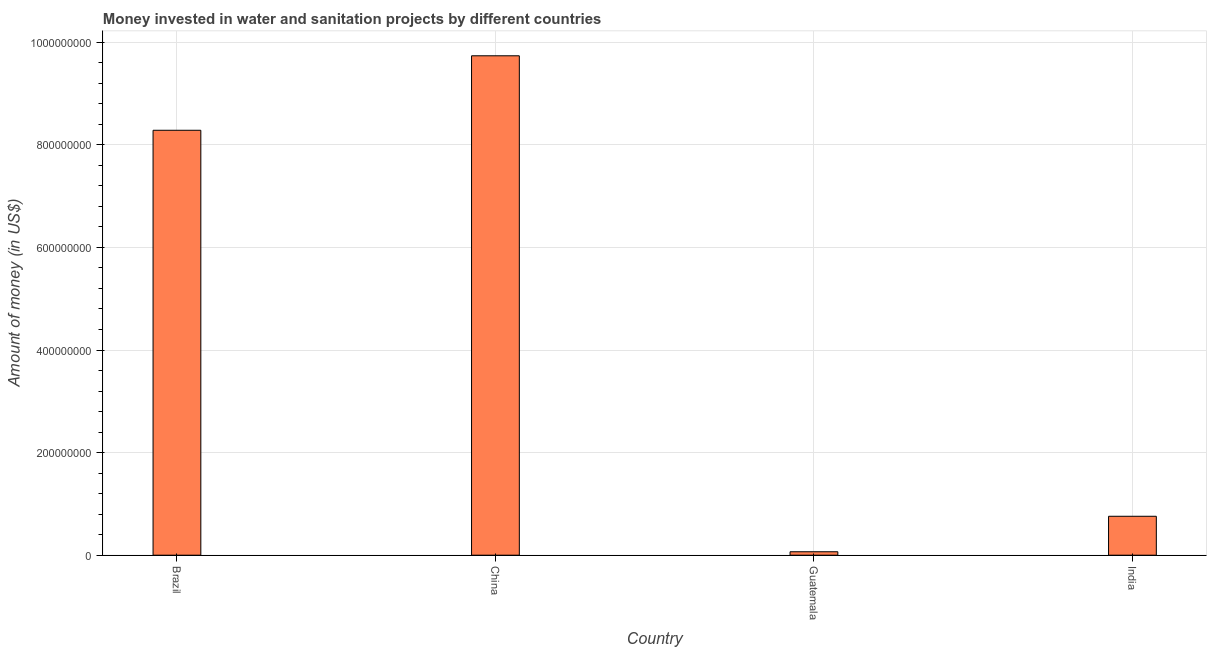Does the graph contain grids?
Give a very brief answer. Yes. What is the title of the graph?
Your answer should be compact. Money invested in water and sanitation projects by different countries. What is the label or title of the Y-axis?
Provide a succinct answer. Amount of money (in US$). What is the investment in China?
Offer a very short reply. 9.74e+08. Across all countries, what is the maximum investment?
Ensure brevity in your answer.  9.74e+08. Across all countries, what is the minimum investment?
Give a very brief answer. 6.70e+06. In which country was the investment minimum?
Keep it short and to the point. Guatemala. What is the sum of the investment?
Your answer should be very brief. 1.88e+09. What is the difference between the investment in Brazil and Guatemala?
Your response must be concise. 8.22e+08. What is the average investment per country?
Provide a succinct answer. 4.71e+08. What is the median investment?
Offer a terse response. 4.52e+08. In how many countries, is the investment greater than 240000000 US$?
Give a very brief answer. 2. What is the ratio of the investment in Brazil to that in India?
Keep it short and to the point. 10.91. What is the difference between the highest and the second highest investment?
Your response must be concise. 1.45e+08. What is the difference between the highest and the lowest investment?
Your answer should be compact. 9.67e+08. How many bars are there?
Your answer should be compact. 4. Are all the bars in the graph horizontal?
Provide a short and direct response. No. What is the difference between two consecutive major ticks on the Y-axis?
Provide a short and direct response. 2.00e+08. Are the values on the major ticks of Y-axis written in scientific E-notation?
Ensure brevity in your answer.  No. What is the Amount of money (in US$) in Brazil?
Keep it short and to the point. 8.28e+08. What is the Amount of money (in US$) in China?
Offer a terse response. 9.74e+08. What is the Amount of money (in US$) of Guatemala?
Your answer should be compact. 6.70e+06. What is the Amount of money (in US$) in India?
Your answer should be very brief. 7.59e+07. What is the difference between the Amount of money (in US$) in Brazil and China?
Provide a succinct answer. -1.45e+08. What is the difference between the Amount of money (in US$) in Brazil and Guatemala?
Your answer should be compact. 8.22e+08. What is the difference between the Amount of money (in US$) in Brazil and India?
Give a very brief answer. 7.52e+08. What is the difference between the Amount of money (in US$) in China and Guatemala?
Make the answer very short. 9.67e+08. What is the difference between the Amount of money (in US$) in China and India?
Keep it short and to the point. 8.98e+08. What is the difference between the Amount of money (in US$) in Guatemala and India?
Offer a terse response. -6.92e+07. What is the ratio of the Amount of money (in US$) in Brazil to that in China?
Your answer should be very brief. 0.85. What is the ratio of the Amount of money (in US$) in Brazil to that in Guatemala?
Offer a very short reply. 123.64. What is the ratio of the Amount of money (in US$) in Brazil to that in India?
Offer a terse response. 10.91. What is the ratio of the Amount of money (in US$) in China to that in Guatemala?
Give a very brief answer. 145.31. What is the ratio of the Amount of money (in US$) in China to that in India?
Provide a succinct answer. 12.83. What is the ratio of the Amount of money (in US$) in Guatemala to that in India?
Provide a short and direct response. 0.09. 